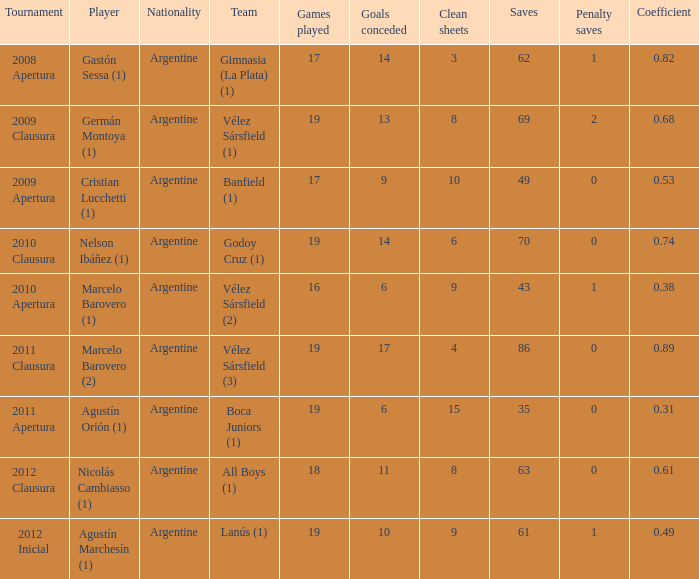Which team was in the 2012 clausura tournament? All Boys (1). 